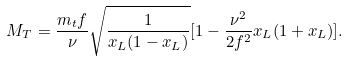Convert formula to latex. <formula><loc_0><loc_0><loc_500><loc_500>M _ { T } = \frac { m _ { t } f } { \nu } \sqrt { \frac { 1 } { x _ { L } ( 1 - x _ { L } ) } } [ 1 - \frac { \nu ^ { 2 } } { 2 f ^ { 2 } } x _ { L } ( 1 + x _ { L } ) ] .</formula> 